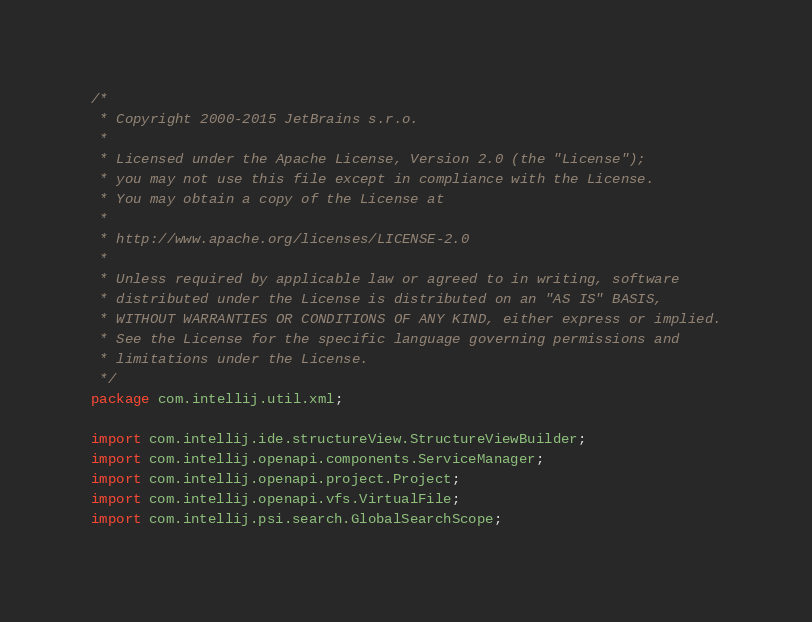<code> <loc_0><loc_0><loc_500><loc_500><_Java_>/*
 * Copyright 2000-2015 JetBrains s.r.o.
 *
 * Licensed under the Apache License, Version 2.0 (the "License");
 * you may not use this file except in compliance with the License.
 * You may obtain a copy of the License at
 *
 * http://www.apache.org/licenses/LICENSE-2.0
 *
 * Unless required by applicable law or agreed to in writing, software
 * distributed under the License is distributed on an "AS IS" BASIS,
 * WITHOUT WARRANTIES OR CONDITIONS OF ANY KIND, either express or implied.
 * See the License for the specific language governing permissions and
 * limitations under the License.
 */
package com.intellij.util.xml;

import com.intellij.ide.structureView.StructureViewBuilder;
import com.intellij.openapi.components.ServiceManager;
import com.intellij.openapi.project.Project;
import com.intellij.openapi.vfs.VirtualFile;
import com.intellij.psi.search.GlobalSearchScope;</code> 